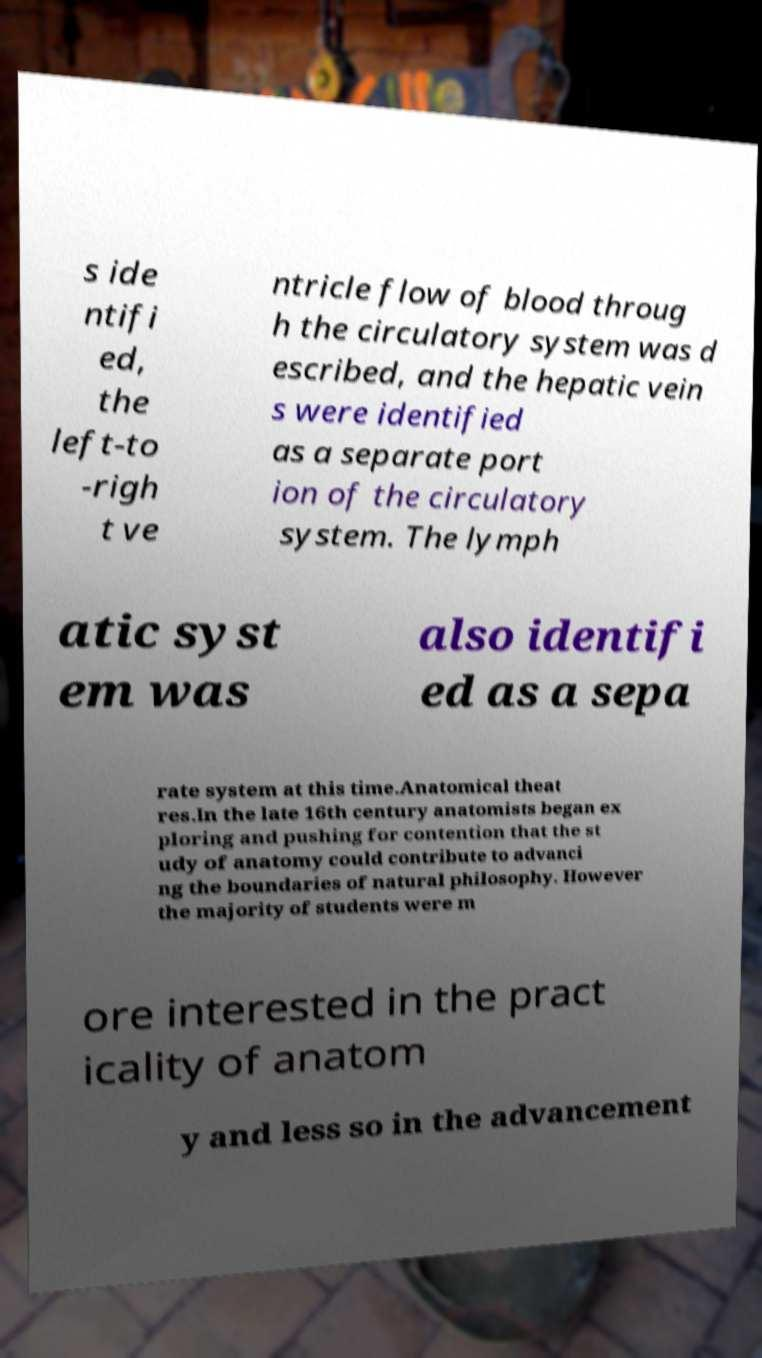Could you assist in decoding the text presented in this image and type it out clearly? s ide ntifi ed, the left-to -righ t ve ntricle flow of blood throug h the circulatory system was d escribed, and the hepatic vein s were identified as a separate port ion of the circulatory system. The lymph atic syst em was also identifi ed as a sepa rate system at this time.Anatomical theat res.In the late 16th century anatomists began ex ploring and pushing for contention that the st udy of anatomy could contribute to advanci ng the boundaries of natural philosophy. However the majority of students were m ore interested in the pract icality of anatom y and less so in the advancement 